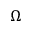<formula> <loc_0><loc_0><loc_500><loc_500>\Omega</formula> 